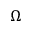<formula> <loc_0><loc_0><loc_500><loc_500>\Omega</formula> 